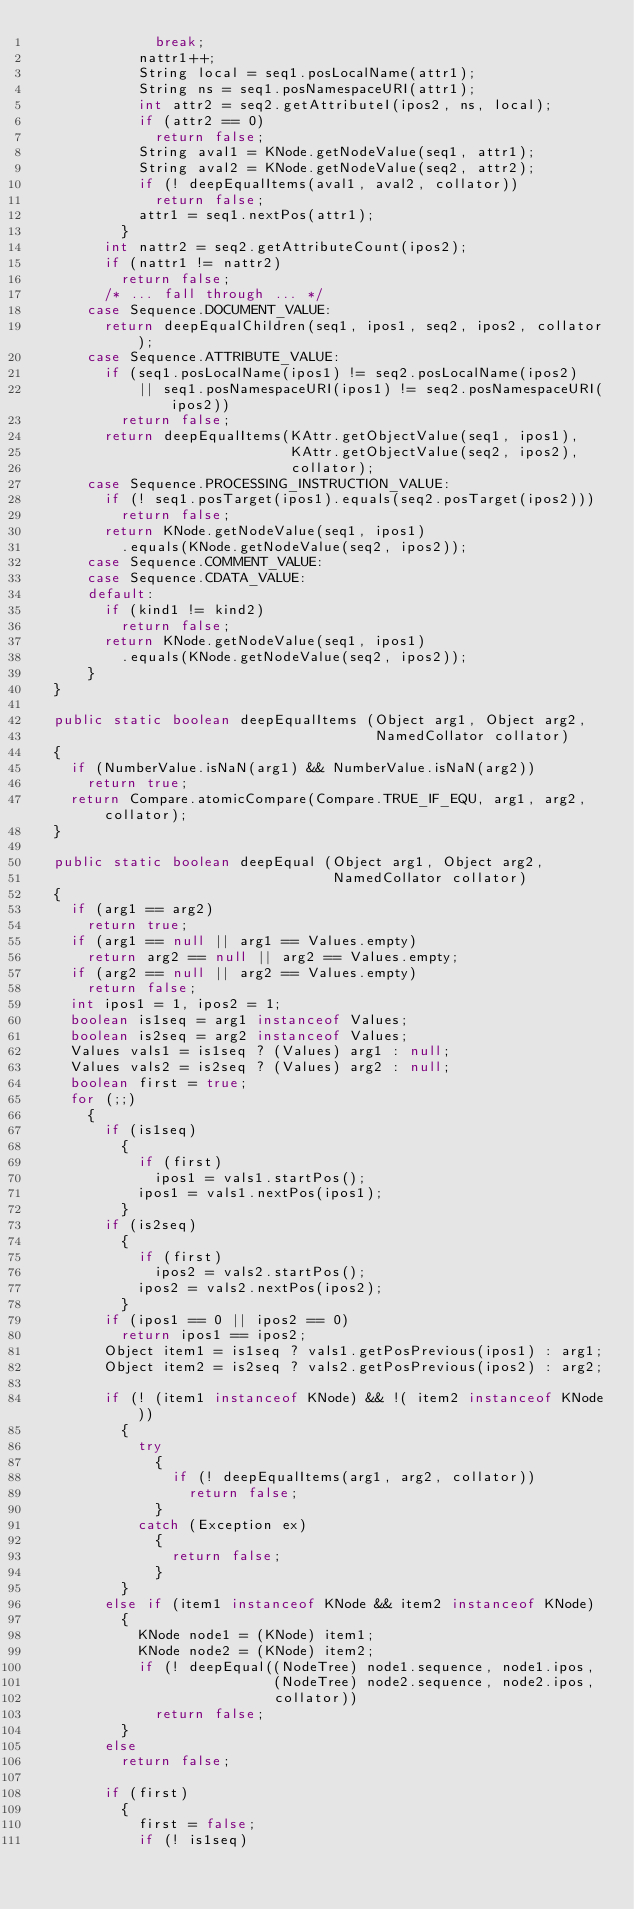Convert code to text. <code><loc_0><loc_0><loc_500><loc_500><_Java_>              break;
            nattr1++;
            String local = seq1.posLocalName(attr1);
            String ns = seq1.posNamespaceURI(attr1);
            int attr2 = seq2.getAttributeI(ipos2, ns, local);
            if (attr2 == 0)
              return false;
            String aval1 = KNode.getNodeValue(seq1, attr1);
            String aval2 = KNode.getNodeValue(seq2, attr2);
            if (! deepEqualItems(aval1, aval2, collator))
              return false;
            attr1 = seq1.nextPos(attr1);
          }
        int nattr2 = seq2.getAttributeCount(ipos2);
        if (nattr1 != nattr2)
          return false;
        /* ... fall through ... */
      case Sequence.DOCUMENT_VALUE:
        return deepEqualChildren(seq1, ipos1, seq2, ipos2, collator);
      case Sequence.ATTRIBUTE_VALUE:
        if (seq1.posLocalName(ipos1) != seq2.posLocalName(ipos2)
            || seq1.posNamespaceURI(ipos1) != seq2.posNamespaceURI(ipos2))
          return false;
        return deepEqualItems(KAttr.getObjectValue(seq1, ipos1),
                              KAttr.getObjectValue(seq2, ipos2),
                              collator);
      case Sequence.PROCESSING_INSTRUCTION_VALUE:
        if (! seq1.posTarget(ipos1).equals(seq2.posTarget(ipos2)))
          return false;
        return KNode.getNodeValue(seq1, ipos1)
          .equals(KNode.getNodeValue(seq2, ipos2));
      case Sequence.COMMENT_VALUE:
      case Sequence.CDATA_VALUE:
      default:
        if (kind1 != kind2)
          return false;
        return KNode.getNodeValue(seq1, ipos1)
          .equals(KNode.getNodeValue(seq2, ipos2));
      }
  }

  public static boolean deepEqualItems (Object arg1, Object arg2,
                                        NamedCollator collator)
  {
    if (NumberValue.isNaN(arg1) && NumberValue.isNaN(arg2))
      return true;
    return Compare.atomicCompare(Compare.TRUE_IF_EQU, arg1, arg2, collator);
  }

  public static boolean deepEqual (Object arg1, Object arg2,
                                   NamedCollator collator)
  {
    if (arg1 == arg2)
      return true;
    if (arg1 == null || arg1 == Values.empty)
      return arg2 == null || arg2 == Values.empty;
    if (arg2 == null || arg2 == Values.empty)
      return false;
    int ipos1 = 1, ipos2 = 1;
    boolean is1seq = arg1 instanceof Values;
    boolean is2seq = arg2 instanceof Values;
    Values vals1 = is1seq ? (Values) arg1 : null;
    Values vals2 = is2seq ? (Values) arg2 : null;
    boolean first = true;
    for (;;)
      {
        if (is1seq)
          {
            if (first)
              ipos1 = vals1.startPos();
            ipos1 = vals1.nextPos(ipos1);
          }
        if (is2seq)
          {
            if (first)
              ipos2 = vals2.startPos();
            ipos2 = vals2.nextPos(ipos2);
          }
        if (ipos1 == 0 || ipos2 == 0)
          return ipos1 == ipos2;
        Object item1 = is1seq ? vals1.getPosPrevious(ipos1) : arg1;
        Object item2 = is2seq ? vals2.getPosPrevious(ipos2) : arg2;

        if (! (item1 instanceof KNode) && !( item2 instanceof KNode))
          {
            try
              {
                if (! deepEqualItems(arg1, arg2, collator))
                  return false;
              }
            catch (Exception ex)
              {
                return false;
              }
          }
        else if (item1 instanceof KNode && item2 instanceof KNode)
          {
            KNode node1 = (KNode) item1;
            KNode node2 = (KNode) item2;
            if (! deepEqual((NodeTree) node1.sequence, node1.ipos,
                            (NodeTree) node2.sequence, node2.ipos,
                            collator))
              return false;
          }
        else
          return false;

        if (first)
          {
            first = false;
            if (! is1seq)</code> 